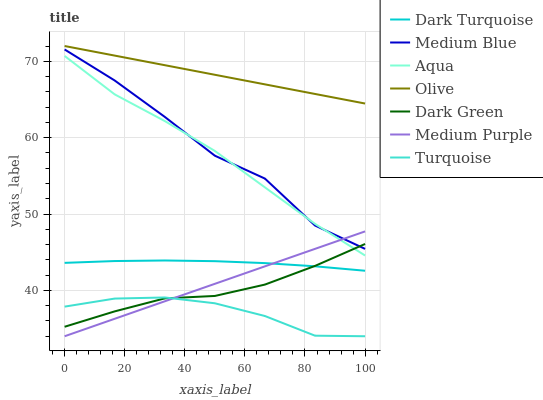Does Turquoise have the minimum area under the curve?
Answer yes or no. Yes. Does Olive have the maximum area under the curve?
Answer yes or no. Yes. Does Dark Turquoise have the minimum area under the curve?
Answer yes or no. No. Does Dark Turquoise have the maximum area under the curve?
Answer yes or no. No. Is Medium Purple the smoothest?
Answer yes or no. Yes. Is Medium Blue the roughest?
Answer yes or no. Yes. Is Dark Turquoise the smoothest?
Answer yes or no. No. Is Dark Turquoise the roughest?
Answer yes or no. No. Does Turquoise have the lowest value?
Answer yes or no. Yes. Does Dark Turquoise have the lowest value?
Answer yes or no. No. Does Olive have the highest value?
Answer yes or no. Yes. Does Dark Turquoise have the highest value?
Answer yes or no. No. Is Turquoise less than Olive?
Answer yes or no. Yes. Is Olive greater than Medium Blue?
Answer yes or no. Yes. Does Dark Green intersect Dark Turquoise?
Answer yes or no. Yes. Is Dark Green less than Dark Turquoise?
Answer yes or no. No. Is Dark Green greater than Dark Turquoise?
Answer yes or no. No. Does Turquoise intersect Olive?
Answer yes or no. No. 